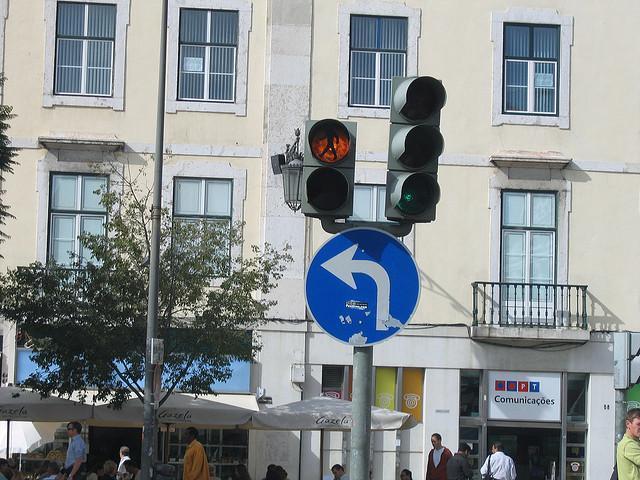What is the sign telling drivers?
From the following set of four choices, select the accurate answer to respond to the question.
Options: Left only, go straight, no u-turns, right only. Left only. 